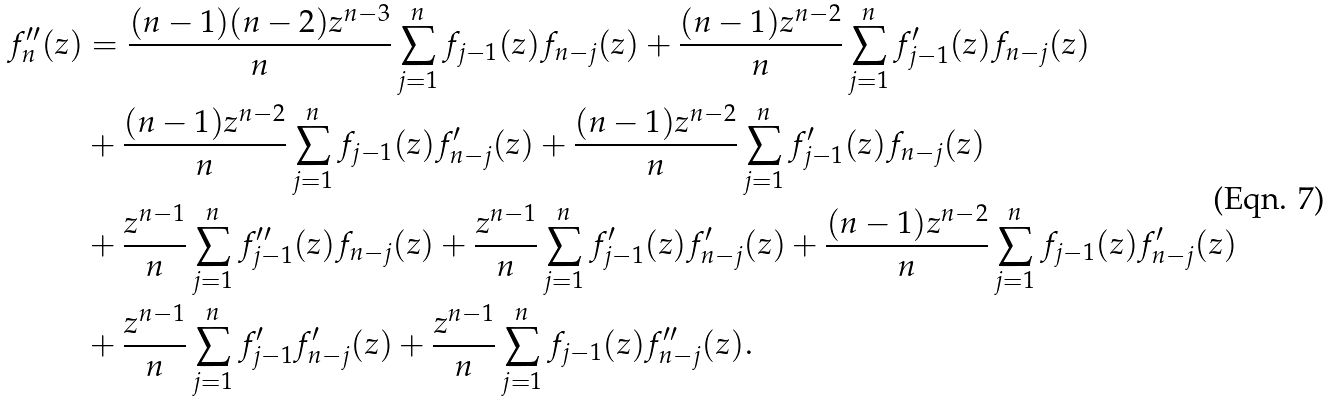Convert formula to latex. <formula><loc_0><loc_0><loc_500><loc_500>f ^ { \prime \prime } _ { n } ( z ) & = \frac { ( n - 1 ) ( n - 2 ) z ^ { n - 3 } } { n } \sum _ { j = 1 } ^ { n } f _ { j - 1 } ( z ) f _ { n - j } ( z ) + \frac { ( n - 1 ) z ^ { n - 2 } } { n } \sum _ { j = 1 } ^ { n } f ^ { \prime } _ { j - 1 } ( z ) f _ { n - j } ( z ) \\ & + \frac { ( n - 1 ) z ^ { n - 2 } } { n } \sum _ { j = 1 } ^ { n } f _ { j - 1 } ( z ) f ^ { \prime } _ { n - j } ( z ) + \frac { ( n - 1 ) z ^ { n - 2 } } { n } \sum _ { j = 1 } ^ { n } f ^ { \prime } _ { j - 1 } ( z ) f _ { n - j } ( z ) \\ & + \frac { z ^ { n - 1 } } { n } \sum _ { j = 1 } ^ { n } f ^ { \prime \prime } _ { j - 1 } ( z ) f _ { n - j } ( z ) + \frac { z ^ { n - 1 } } { n } \sum _ { j = 1 } ^ { n } f ^ { \prime } _ { j - 1 } ( z ) f ^ { \prime } _ { n - j } ( z ) + \frac { ( n - 1 ) z ^ { n - 2 } } { n } \sum _ { j = 1 } ^ { n } f _ { j - 1 } ( z ) f ^ { \prime } _ { n - j } ( z ) \\ & + \frac { z ^ { n - 1 } } { n } \sum _ { j = 1 } ^ { n } f ^ { \prime } _ { j - 1 } f ^ { \prime } _ { n - j } ( z ) + \frac { z ^ { n - 1 } } { n } \sum _ { j = 1 } ^ { n } f _ { j - 1 } ( z ) f ^ { \prime \prime } _ { n - j } ( z ) .</formula> 